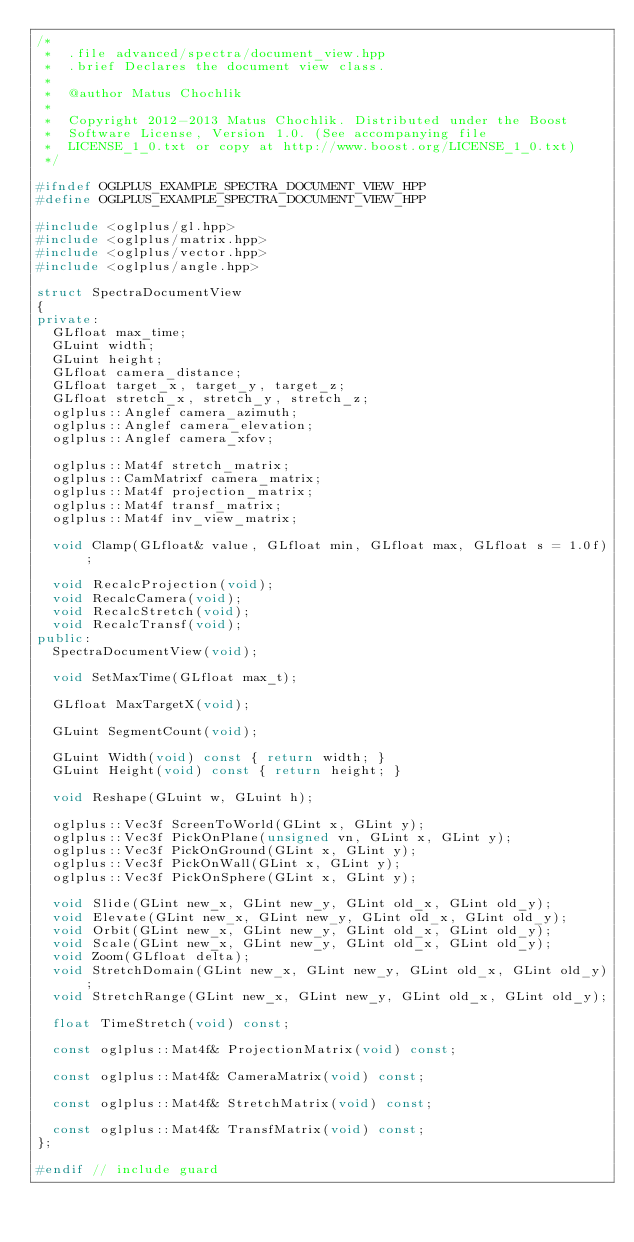<code> <loc_0><loc_0><loc_500><loc_500><_C++_>/*
 *  .file advanced/spectra/document_view.hpp
 *  .brief Declares the document view class.
 *
 *  @author Matus Chochlik
 *
 *  Copyright 2012-2013 Matus Chochlik. Distributed under the Boost
 *  Software License, Version 1.0. (See accompanying file
 *  LICENSE_1_0.txt or copy at http://www.boost.org/LICENSE_1_0.txt)
 */

#ifndef OGLPLUS_EXAMPLE_SPECTRA_DOCUMENT_VIEW_HPP
#define OGLPLUS_EXAMPLE_SPECTRA_DOCUMENT_VIEW_HPP

#include <oglplus/gl.hpp>
#include <oglplus/matrix.hpp>
#include <oglplus/vector.hpp>
#include <oglplus/angle.hpp>

struct SpectraDocumentView
{
private:
	GLfloat max_time;
	GLuint width;
	GLuint height;
	GLfloat camera_distance;
	GLfloat target_x, target_y, target_z;
	GLfloat stretch_x, stretch_y, stretch_z;
	oglplus::Anglef camera_azimuth;
	oglplus::Anglef camera_elevation;
	oglplus::Anglef camera_xfov;

	oglplus::Mat4f stretch_matrix;
	oglplus::CamMatrixf camera_matrix;
	oglplus::Mat4f projection_matrix;
	oglplus::Mat4f transf_matrix;
	oglplus::Mat4f inv_view_matrix;

	void Clamp(GLfloat& value, GLfloat min, GLfloat max, GLfloat s = 1.0f);

	void RecalcProjection(void);
	void RecalcCamera(void);
	void RecalcStretch(void);
	void RecalcTransf(void);
public:
	SpectraDocumentView(void);

	void SetMaxTime(GLfloat max_t);

	GLfloat MaxTargetX(void);

	GLuint SegmentCount(void);

	GLuint Width(void) const { return width; }
	GLuint Height(void) const { return height; }

	void Reshape(GLuint w, GLuint h);

	oglplus::Vec3f ScreenToWorld(GLint x, GLint y);
	oglplus::Vec3f PickOnPlane(unsigned vn, GLint x, GLint y);
	oglplus::Vec3f PickOnGround(GLint x, GLint y);
	oglplus::Vec3f PickOnWall(GLint x, GLint y);
	oglplus::Vec3f PickOnSphere(GLint x, GLint y);

	void Slide(GLint new_x, GLint new_y, GLint old_x, GLint old_y);
	void Elevate(GLint new_x, GLint new_y, GLint old_x, GLint old_y);
	void Orbit(GLint new_x, GLint new_y, GLint old_x, GLint old_y);
	void Scale(GLint new_x, GLint new_y, GLint old_x, GLint old_y);
	void Zoom(GLfloat delta);
	void StretchDomain(GLint new_x, GLint new_y, GLint old_x, GLint old_y);
	void StretchRange(GLint new_x, GLint new_y, GLint old_x, GLint old_y);

	float TimeStretch(void) const;

	const oglplus::Mat4f& ProjectionMatrix(void) const;

	const oglplus::Mat4f& CameraMatrix(void) const;

	const oglplus::Mat4f& StretchMatrix(void) const;

	const oglplus::Mat4f& TransfMatrix(void) const;
};

#endif // include guard
</code> 